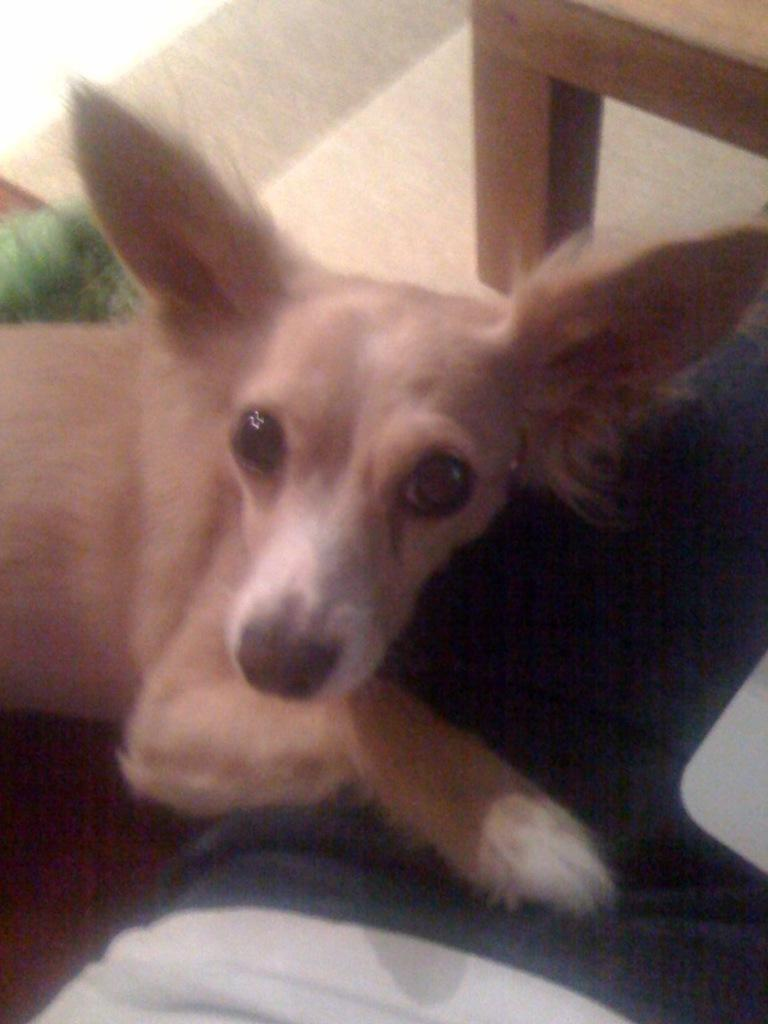What animal can be seen in the image? There is a dog in the image. What is the dog doing in the image? The dog is sitting on the floor and looking at a picture. What else can be seen in the image besides the dog? There are clothes visible in the image, and there is a chair located on the right top. What time is the hourglass showing in the image? There is no hourglass present in the image. What type of friction is the dog experiencing while sitting on the floor? The dog's experience of friction is not mentioned in the image, and it is not necessary to determine the dog's comfort or position. 